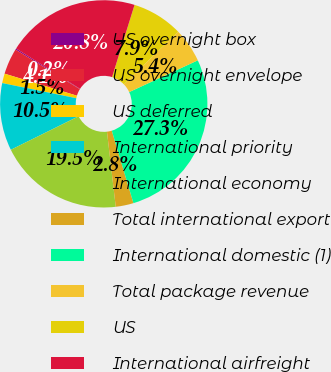<chart> <loc_0><loc_0><loc_500><loc_500><pie_chart><fcel>US overnight box<fcel>US overnight envelope<fcel>US deferred<fcel>International priority<fcel>International economy<fcel>Total international export<fcel>International domestic (1)<fcel>Total package revenue<fcel>US<fcel>International airfreight<nl><fcel>0.2%<fcel>4.07%<fcel>1.49%<fcel>10.52%<fcel>19.54%<fcel>2.78%<fcel>27.27%<fcel>5.36%<fcel>7.94%<fcel>20.83%<nl></chart> 